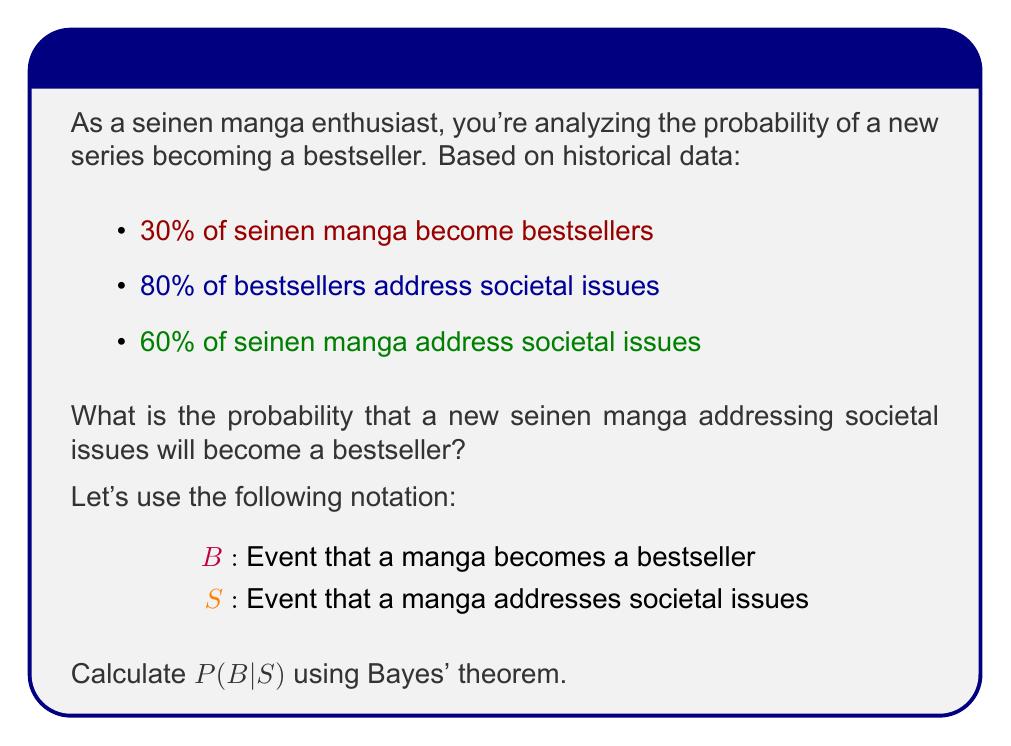Can you solve this math problem? To solve this problem, we'll use Bayes' theorem:

$$P(B|S) = \frac{P(S|B) \cdot P(B)}{P(S)}$$

Given:
- P(B) = 0.30 (30% of seinen manga become bestsellers)
- P(S|B) = 0.80 (80% of bestsellers address societal issues)
- P(S) = 0.60 (60% of seinen manga address societal issues)

Step 1: Apply Bayes' theorem
$$P(B|S) = \frac{0.80 \cdot 0.30}{0.60}$$

Step 2: Calculate
$$P(B|S) = \frac{0.24}{0.60} = 0.40$$

Step 3: Convert to percentage
0.40 * 100 = 40%

Therefore, the probability that a new seinen manga addressing societal issues will become a bestseller is 40%.

This result aligns with the persona's interest in seinen manga that explore societal issues, showing that such works have a higher chance of becoming bestsellers compared to the overall seinen category (40% vs 30%).
Answer: 40% 